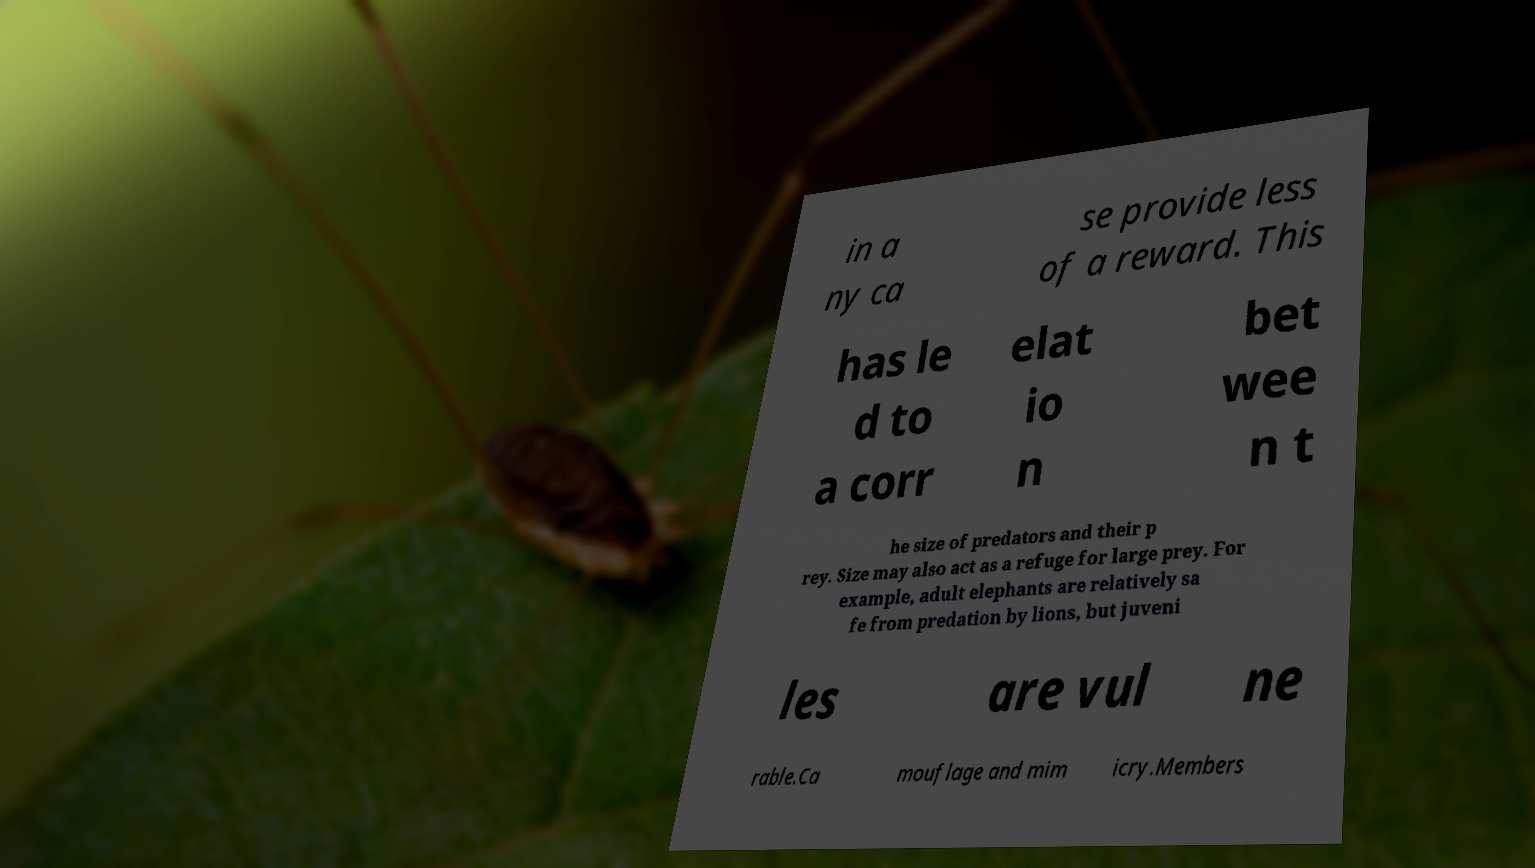What messages or text are displayed in this image? I need them in a readable, typed format. in a ny ca se provide less of a reward. This has le d to a corr elat io n bet wee n t he size of predators and their p rey. Size may also act as a refuge for large prey. For example, adult elephants are relatively sa fe from predation by lions, but juveni les are vul ne rable.Ca mouflage and mim icry.Members 